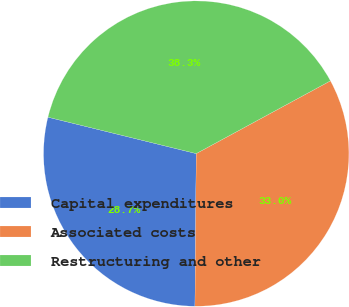Convert chart to OTSL. <chart><loc_0><loc_0><loc_500><loc_500><pie_chart><fcel>Capital expenditures<fcel>Associated costs<fcel>Restructuring and other<nl><fcel>28.7%<fcel>33.04%<fcel>38.26%<nl></chart> 